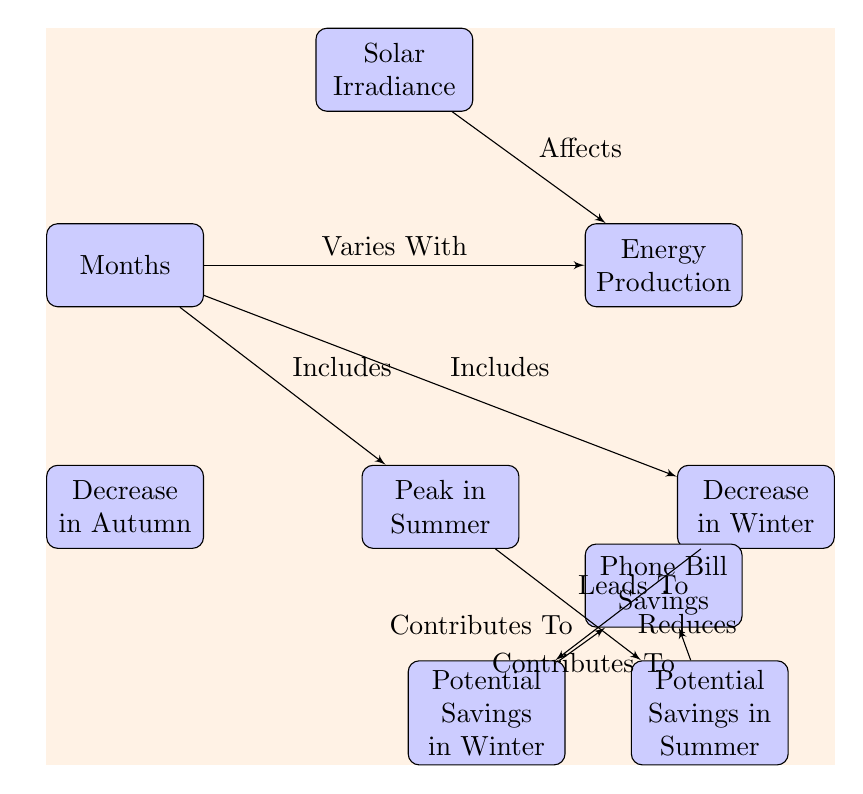What variable affects energy production? The diagram indicates that Solar Irradiance affects Energy Production as represented by the edge connecting these two nodes.
Answer: Solar Irradiance How many months are included in the diagram? The diagram specifically shows "Months" as a block, with edges indicating it varies with energy production and includes seasonal data (summer and winter). Thus, it implies multiple months are represented.
Answer: Multiple Which season leads to peak energy production? The diagram shows an edge from the "summer" node that indicates it leads to potential savings during this peak season, implying that summer is the season with the highest energy production.
Answer: Summer What impact does winter have on savings? The diagram describes "winter" as having a relationship that reduces potential savings, indicated by the edge leading to savings in winter. Therefore, it alters the benefits of savings negatively.
Answer: Reduces How do savings in summer contribute to phone bill savings? The diagram illustrates that potential savings in summer lead to contributing to phone bill savings, showing a direct benefit relationship in terms of monthly expenses reduction.
Answer: Contributes to What seasonal variation is represented alongside decreases? The diagram identifies both "autumn" and "winter" as seasons that include decreases in energy production, indicating that these seasons negatively impact solar energy gains.
Answer: Autumn, Winter How does energy production vary according to months? The diagram describes that energy production is directly tied to the variation in months, showing that the production fluctuates seasonally, being highest in summer and lower in autumn and winter.
Answer: Varies seasonally What is the main consequence of increased solar energy production in summer? The diagram connects "savings_summer" to "phone," suggesting the main consequence of increased solar energy production in summer is directly linked to savings on a phone bill.
Answer: Phone Bill Savings In what season are potential savings highlighted in the diagram? The diagram highlights potential savings in both summer and winter, showing these two seasons specifically as having savings opportunities for users.
Answer: Summer, Winter 